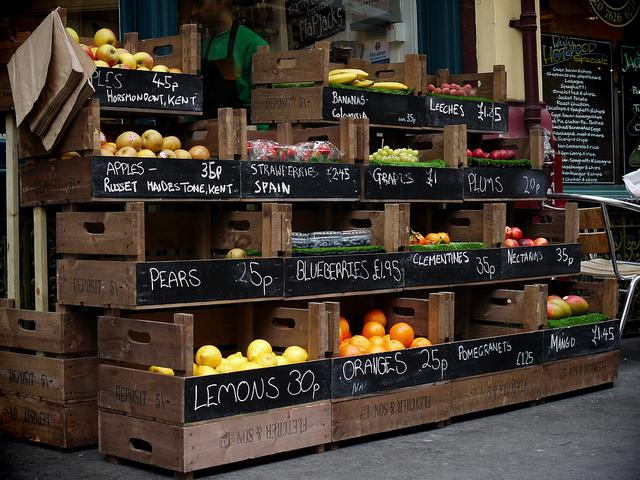What language must someone speak in order to understand what items are offered? english 